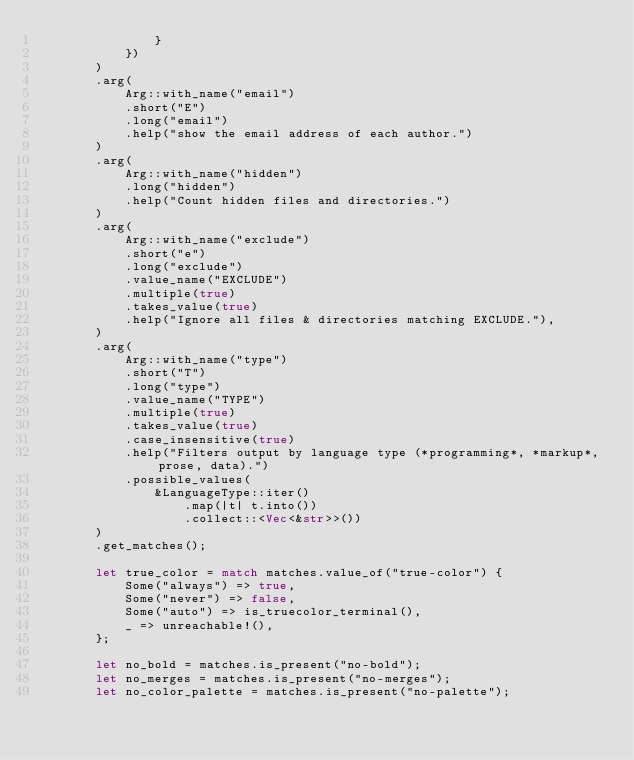Convert code to text. <code><loc_0><loc_0><loc_500><loc_500><_Rust_>                }
            })
        )
        .arg(
            Arg::with_name("email")
            .short("E")
            .long("email")
            .help("show the email address of each author.")
        )
        .arg(
            Arg::with_name("hidden")
            .long("hidden")
            .help("Count hidden files and directories.")
        )
        .arg(
            Arg::with_name("exclude")
            .short("e")
            .long("exclude")
            .value_name("EXCLUDE")
            .multiple(true)
            .takes_value(true)
            .help("Ignore all files & directories matching EXCLUDE."),
        )
        .arg(
            Arg::with_name("type")
            .short("T")
            .long("type")
            .value_name("TYPE")
            .multiple(true)
            .takes_value(true)
            .case_insensitive(true)
            .help("Filters output by language type (*programming*, *markup*, prose, data).")
            .possible_values(
                &LanguageType::iter()
                    .map(|t| t.into())
                    .collect::<Vec<&str>>())
        )
        .get_matches();

        let true_color = match matches.value_of("true-color") {
            Some("always") => true,
            Some("never") => false,
            Some("auto") => is_truecolor_terminal(),
            _ => unreachable!(),
        };

        let no_bold = matches.is_present("no-bold");
        let no_merges = matches.is_present("no-merges");
        let no_color_palette = matches.is_present("no-palette");</code> 